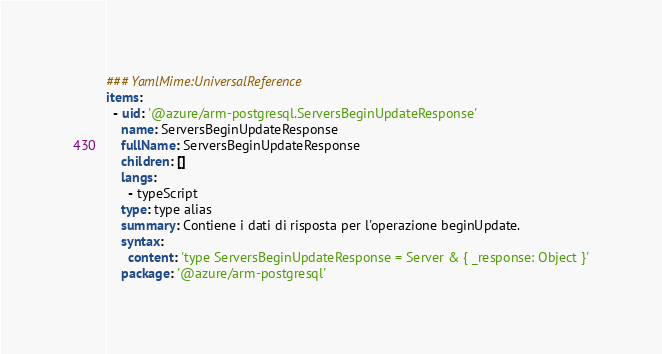<code> <loc_0><loc_0><loc_500><loc_500><_YAML_>### YamlMime:UniversalReference
items:
  - uid: '@azure/arm-postgresql.ServersBeginUpdateResponse'
    name: ServersBeginUpdateResponse
    fullName: ServersBeginUpdateResponse
    children: []
    langs:
      - typeScript
    type: type alias
    summary: Contiene i dati di risposta per l'operazione beginUpdate.
    syntax:
      content: 'type ServersBeginUpdateResponse = Server & { _response: Object }'
    package: '@azure/arm-postgresql'</code> 